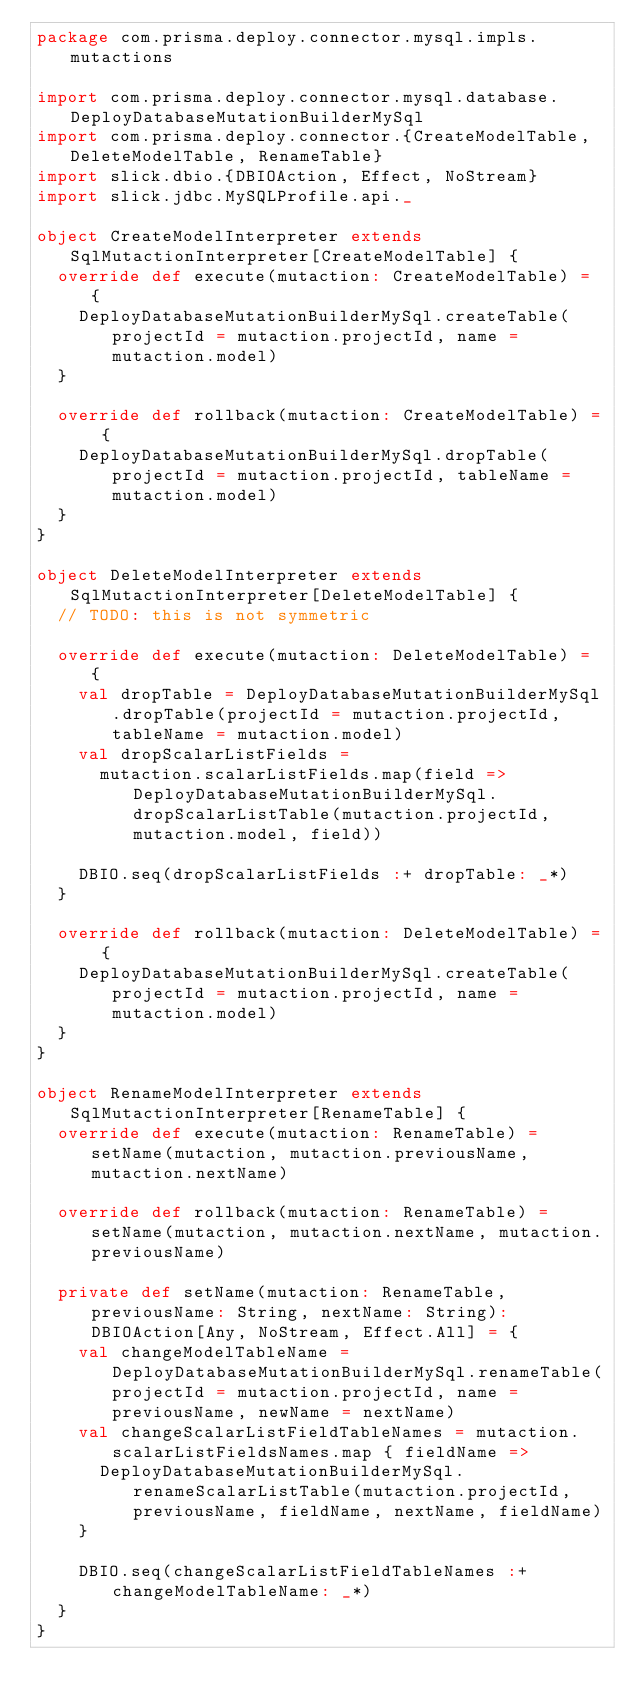Convert code to text. <code><loc_0><loc_0><loc_500><loc_500><_Scala_>package com.prisma.deploy.connector.mysql.impls.mutactions

import com.prisma.deploy.connector.mysql.database.DeployDatabaseMutationBuilderMySql
import com.prisma.deploy.connector.{CreateModelTable, DeleteModelTable, RenameTable}
import slick.dbio.{DBIOAction, Effect, NoStream}
import slick.jdbc.MySQLProfile.api._

object CreateModelInterpreter extends SqlMutactionInterpreter[CreateModelTable] {
  override def execute(mutaction: CreateModelTable) = {
    DeployDatabaseMutationBuilderMySql.createTable(projectId = mutaction.projectId, name = mutaction.model)
  }

  override def rollback(mutaction: CreateModelTable) = {
    DeployDatabaseMutationBuilderMySql.dropTable(projectId = mutaction.projectId, tableName = mutaction.model)
  }
}

object DeleteModelInterpreter extends SqlMutactionInterpreter[DeleteModelTable] {
  // TODO: this is not symmetric

  override def execute(mutaction: DeleteModelTable) = {
    val dropTable = DeployDatabaseMutationBuilderMySql.dropTable(projectId = mutaction.projectId, tableName = mutaction.model)
    val dropScalarListFields =
      mutaction.scalarListFields.map(field => DeployDatabaseMutationBuilderMySql.dropScalarListTable(mutaction.projectId, mutaction.model, field))

    DBIO.seq(dropScalarListFields :+ dropTable: _*)
  }

  override def rollback(mutaction: DeleteModelTable) = {
    DeployDatabaseMutationBuilderMySql.createTable(projectId = mutaction.projectId, name = mutaction.model)
  }
}

object RenameModelInterpreter extends SqlMutactionInterpreter[RenameTable] {
  override def execute(mutaction: RenameTable) = setName(mutaction, mutaction.previousName, mutaction.nextName)

  override def rollback(mutaction: RenameTable) = setName(mutaction, mutaction.nextName, mutaction.previousName)

  private def setName(mutaction: RenameTable, previousName: String, nextName: String): DBIOAction[Any, NoStream, Effect.All] = {
    val changeModelTableName = DeployDatabaseMutationBuilderMySql.renameTable(projectId = mutaction.projectId, name = previousName, newName = nextName)
    val changeScalarListFieldTableNames = mutaction.scalarListFieldsNames.map { fieldName =>
      DeployDatabaseMutationBuilderMySql.renameScalarListTable(mutaction.projectId, previousName, fieldName, nextName, fieldName)
    }

    DBIO.seq(changeScalarListFieldTableNames :+ changeModelTableName: _*)
  }
}
</code> 